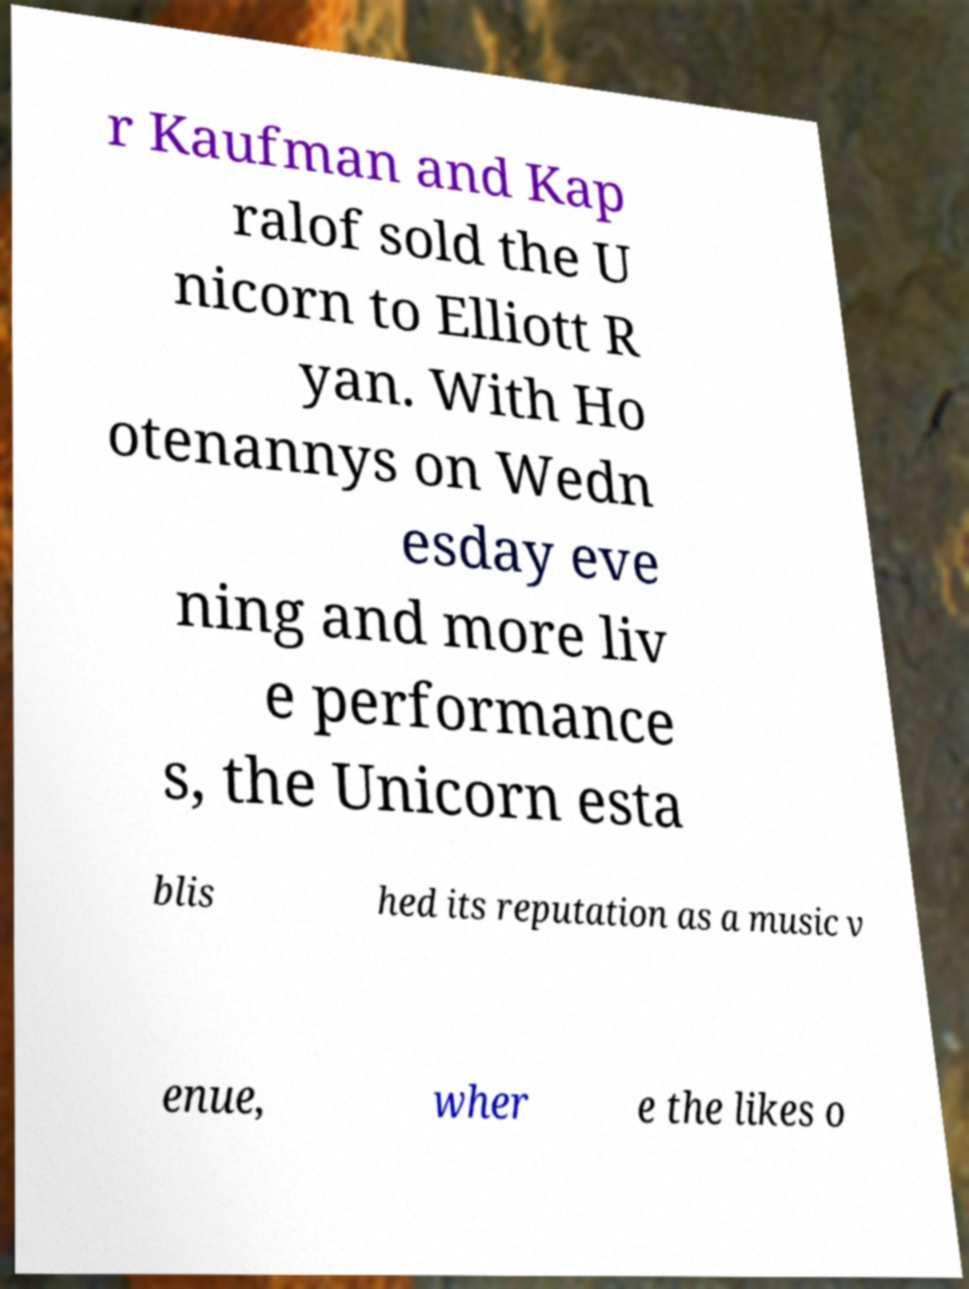I need the written content from this picture converted into text. Can you do that? r Kaufman and Kap ralof sold the U nicorn to Elliott R yan. With Ho otenannys on Wedn esday eve ning and more liv e performance s, the Unicorn esta blis hed its reputation as a music v enue, wher e the likes o 